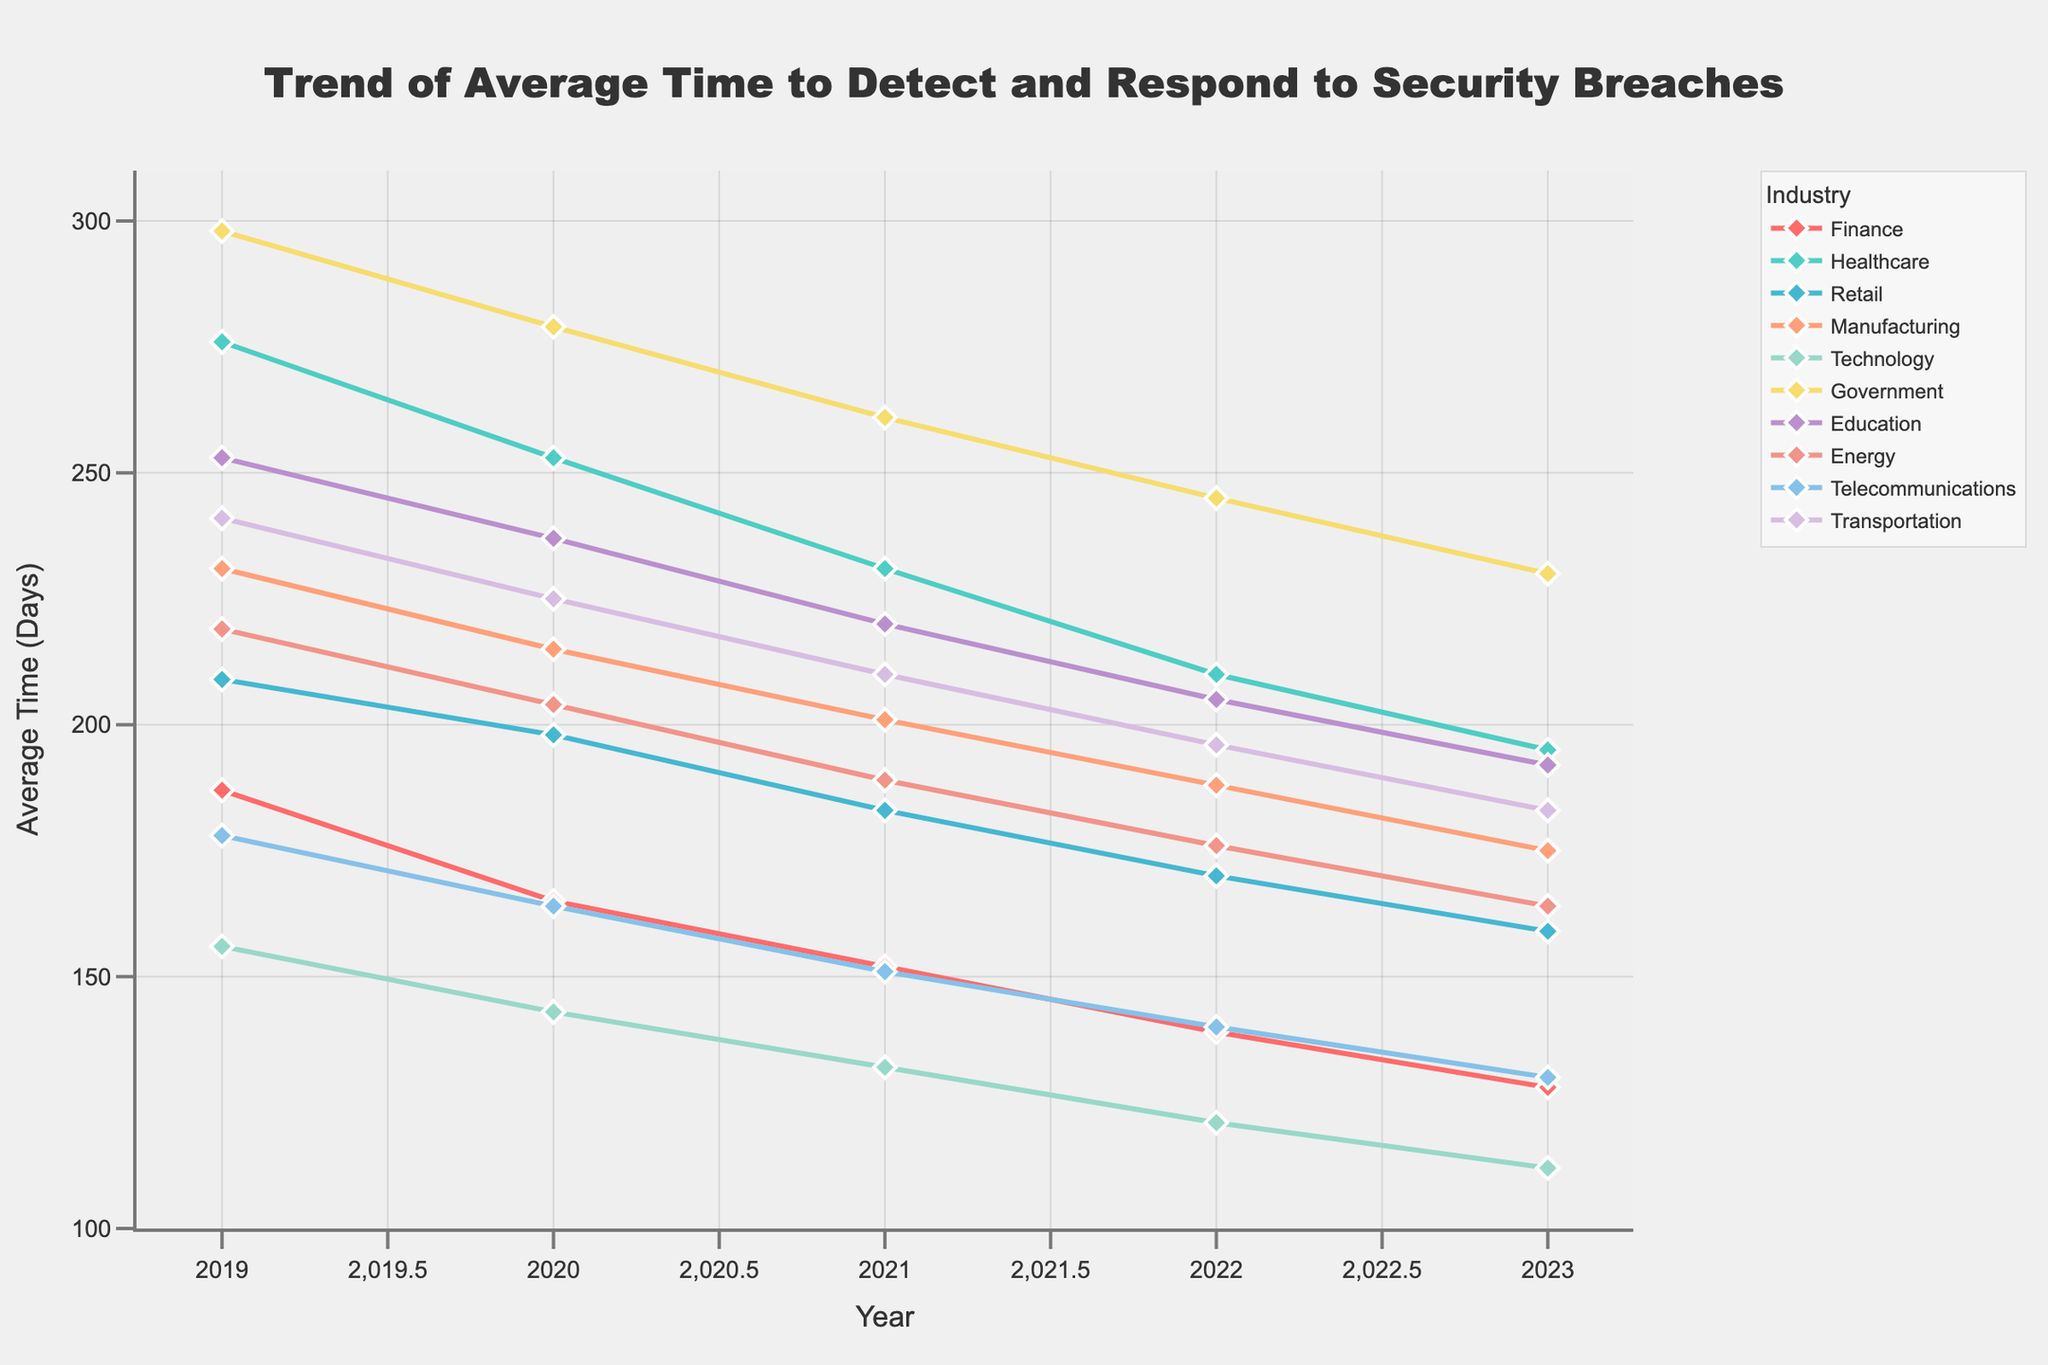Which industry had the highest average time to detect and respond to security breaches in 2023? From the chart, locate the line ending at the highest point on the y-axis corresponding to the year 2023. The highest point is attributed to the Government industry.
Answer: Government How has the average time to detect and respond to security breaches in the Technology industry changed from 2019 to 2023? Observe the trend line for Technology from 2019 to 2023. The line starts at 156 days in 2019 and ends at 112 days in 2023, indicating a decrease.
Answer: Decreased Which industry showed the largest reduction in average time to detect and respond to security breaches from 2019 to 2023? Calculate the difference for each industry between 2019 and 2023. The Government industry reduced its average time from 298 days in 2019 to 230 days in 2023, a reduction of 68 days, the largest among all industries.
Answer: Government What is the difference in average time to detect and respond to security breaches between Healthcare and Retail industries in 2022? Look at the values for Healthcare and Retail in 2022. Healthcare is at 210 days, and Retail is at 170 days. Subtract 170 from 210.
Answer: 40 days Which two industries had the closest average time to detect and respond to security breaches in 2021? Compare the values for each industry in 2021. The closest are Retail (183 days) and Energy (189 days), with a difference of 6 days.
Answer: Retail and Energy Between 2019 and 2023, which industry had the most consistent decrease in the average time to detect and respond to security breaches? Check the slope for each line. Technology shows a consistent downward trend with a relatively even spread between 156 days in 2019 and 112 days in 2023.
Answer: Technology In 2019, which two industries had nearly the same average time to detect and respond to security breaches? Compare the values for each industry in 2019. Healthcare (276 days) and Education (253 days) are the closest.
Answer: Healthcare and Education 